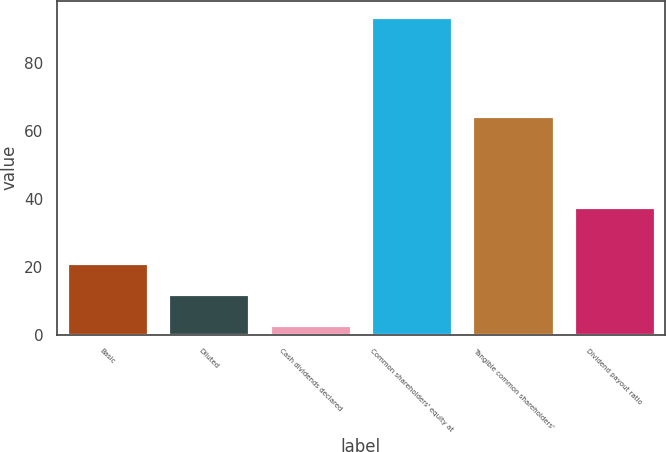<chart> <loc_0><loc_0><loc_500><loc_500><bar_chart><fcel>Basic<fcel>Diluted<fcel>Cash dividends declared<fcel>Common shareholders' equity at<fcel>Tangible common shareholders'<fcel>Dividend payout ratio<nl><fcel>20.96<fcel>11.88<fcel>2.8<fcel>93.6<fcel>64.28<fcel>37.56<nl></chart> 